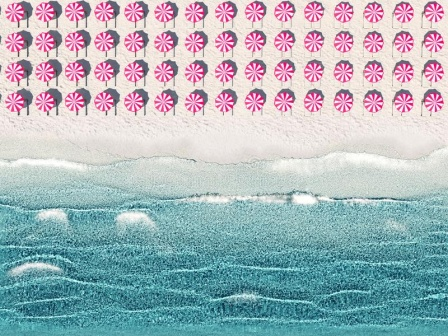Imagine if this beach scene were part of a fantasy world. What characters might inhabit it? In a fantasy world, 'Peppermint Drift Beach' could be home to a range of enchanting characters. For instance, Peppermint Pixies might dwell here, fluttering around the candy-patterned sky, spreading joy and magic. Seafoam Spirits, delicate beings made of the ocean's froth, might dance along the waves, guiding sailors to safe shores. The beach itself could be inhabited by Sand Sculptor Gnomes, tiny artists who craft magnificent castles and sculptures from the grains of sand. Each character contributes to the magical ambiance: Pixies weave threads of light, Spirits sing songs of the sea, and Gnomes infuse the sand with their lifelike creations. Together, they create a harmonious balance, making 'Peppermint Drift Beach' a vibrant polis of whimsical wonder and tranquility. 